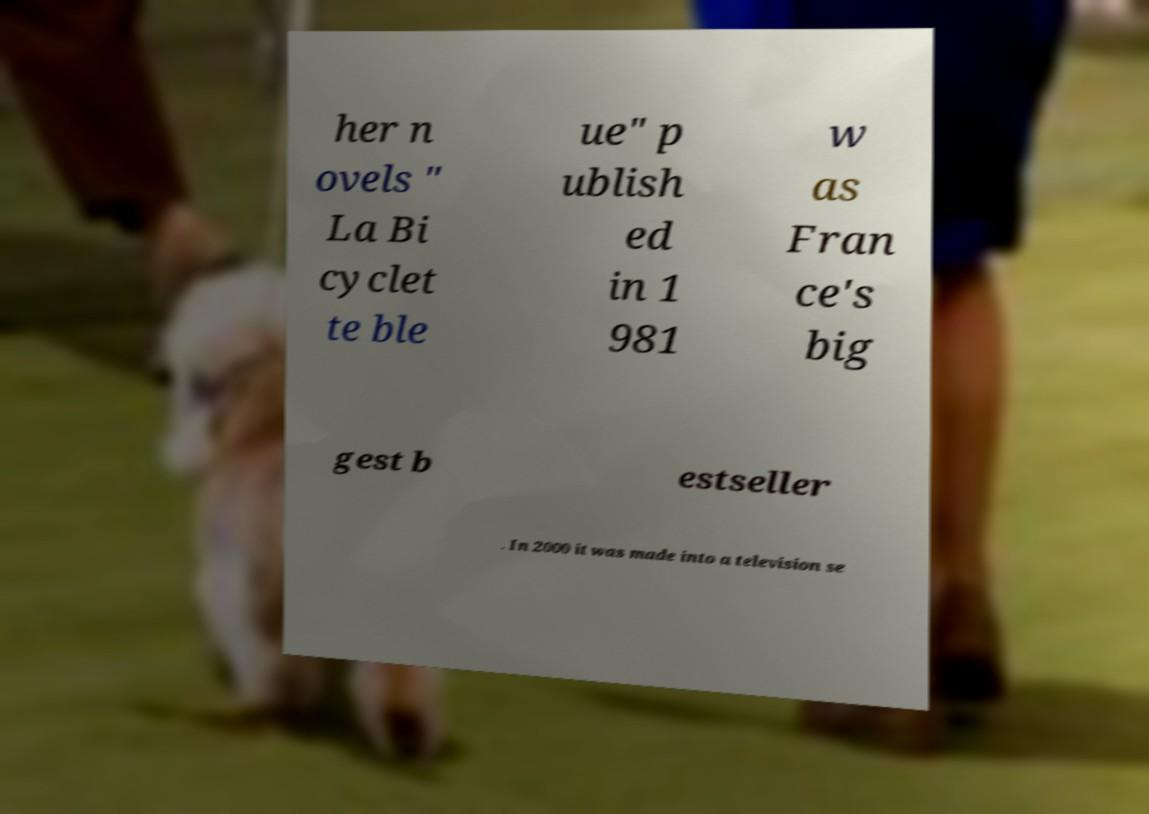Please identify and transcribe the text found in this image. her n ovels " La Bi cyclet te ble ue" p ublish ed in 1 981 w as Fran ce's big gest b estseller . In 2000 it was made into a television se 